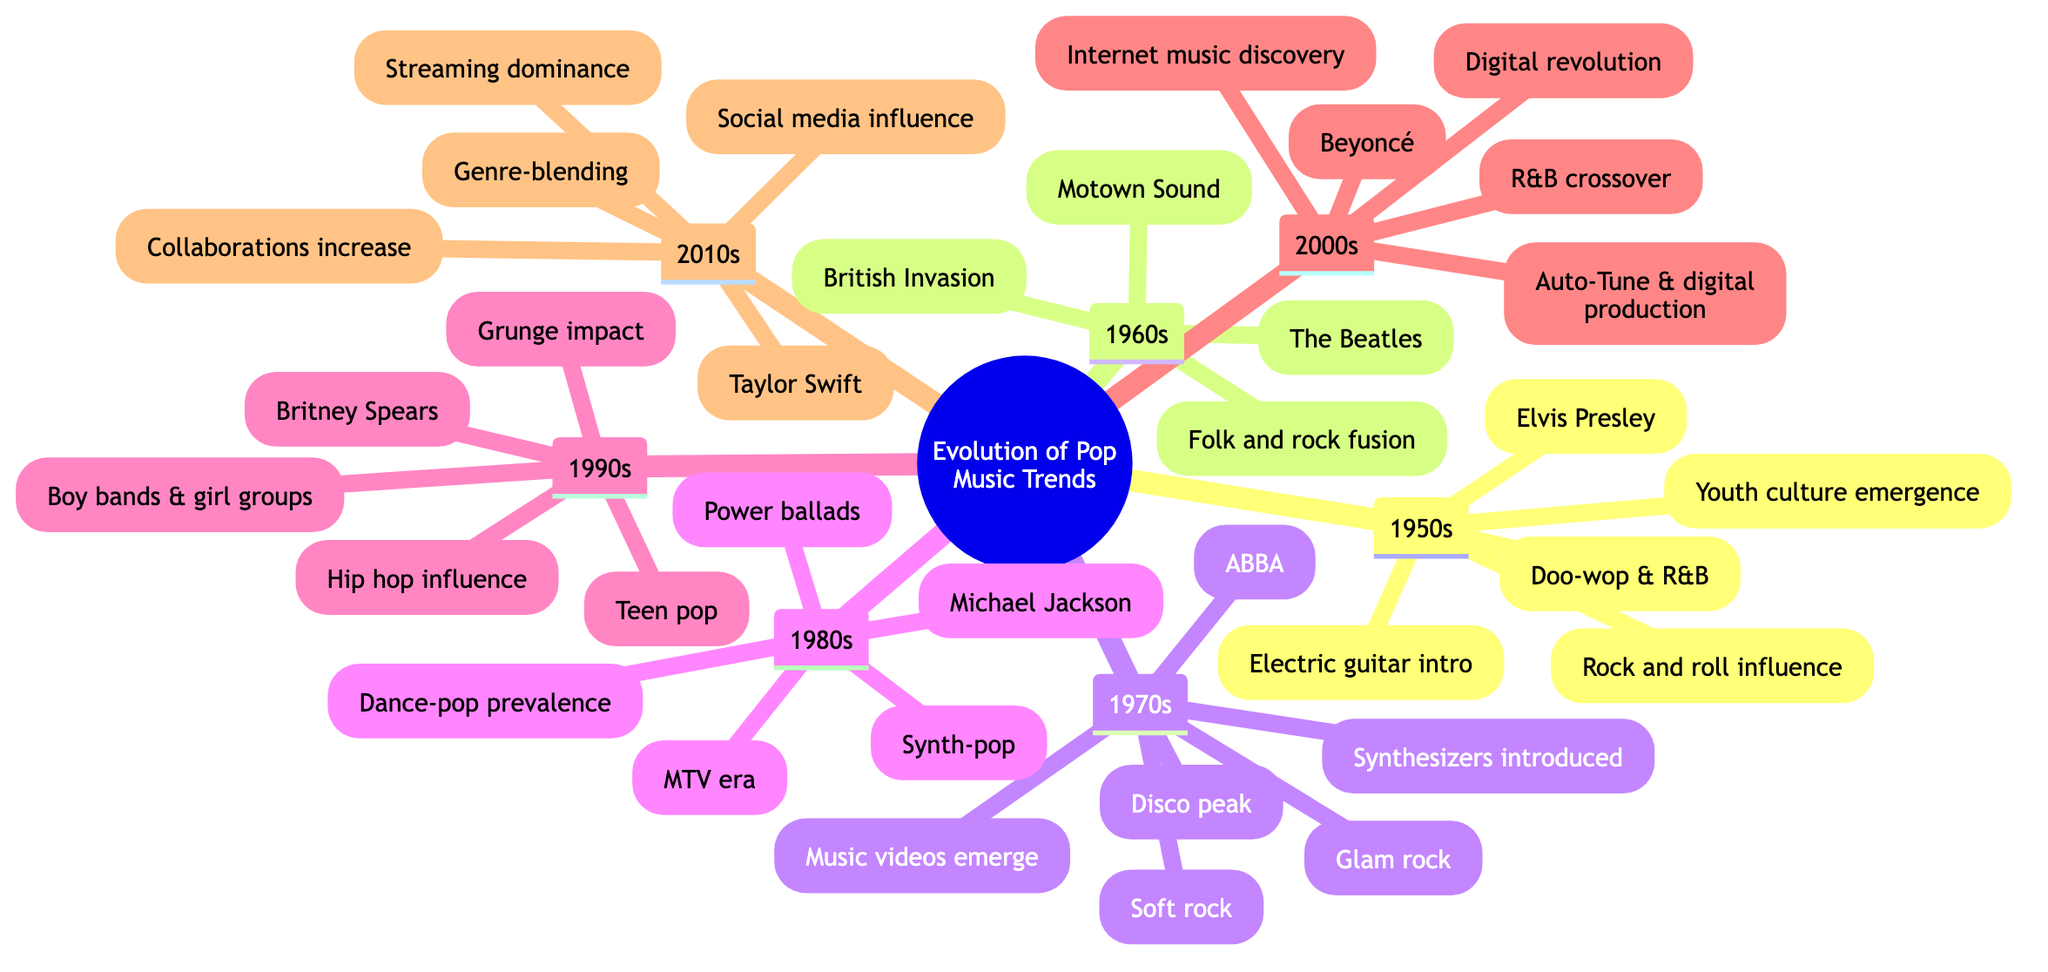What is the key artist of the 1980s? The 1980s section lists Michael Jackson as one of its key artists. Therefore, the answer is derived directly from this node in the diagram.
Answer: Michael Jackson How many decades are represented in the diagram? To determine this, I count the individual decades listed under the main title, which are the 1950s, 1960s, 1970s, 1980s, 1990s, 2000s, and 2010s. This totals to seven decades.
Answer: 7 What trend is associated with the 2000s? The diagram highlights "Auto-Tune and digital production" as a trend specific to the 2000s. To answer this, I reference the corresponding node and extract this information.
Answer: Auto-Tune and digital production Which decade marked the peak of disco? By reviewing the trends associated with each decade, it is clear from the 1970s node that the peak of disco occurred during this decade. Therefore, I identify 1970s as the correct decade.
Answer: 1970s What influenced pop music in the 1990s? The 1990s section mentions influences such as "teen pop", "hip hop influence", and "grunge impact." To form my answer, I gather the notable influences listed in this node.
Answer: Teen pop, hip hop influence, grunge impact Which key artist emerged from the 1960s? The 1960s section includes The Beatles as one of its prominent artists. I locate the 1960s node and retrieve the name listed there as a key artist contributing to that decade.
Answer: The Beatles What trend became essential in the 1980s? The diagram notes that in the 1980s, "Music videos becoming essential" was a key trend. I check this node and extract the specific trend related to the 1980s music landscape.
Answer: Music videos becoming essential What common theme is found in the 2010s with respect to music distribution? The 2010s section indicates the "Rise of streaming platforms" as a significant trend. To derive this answer, I refer to the identified trends in this decade node.
Answer: Rise of streaming platforms Which two genres were blended in the 2010s? The 2010s section reveals "Genre-blending and collaborations" as part of its trends. I consider the information provided in the node to answer the question regarding genres.
Answer: Genre-blending 